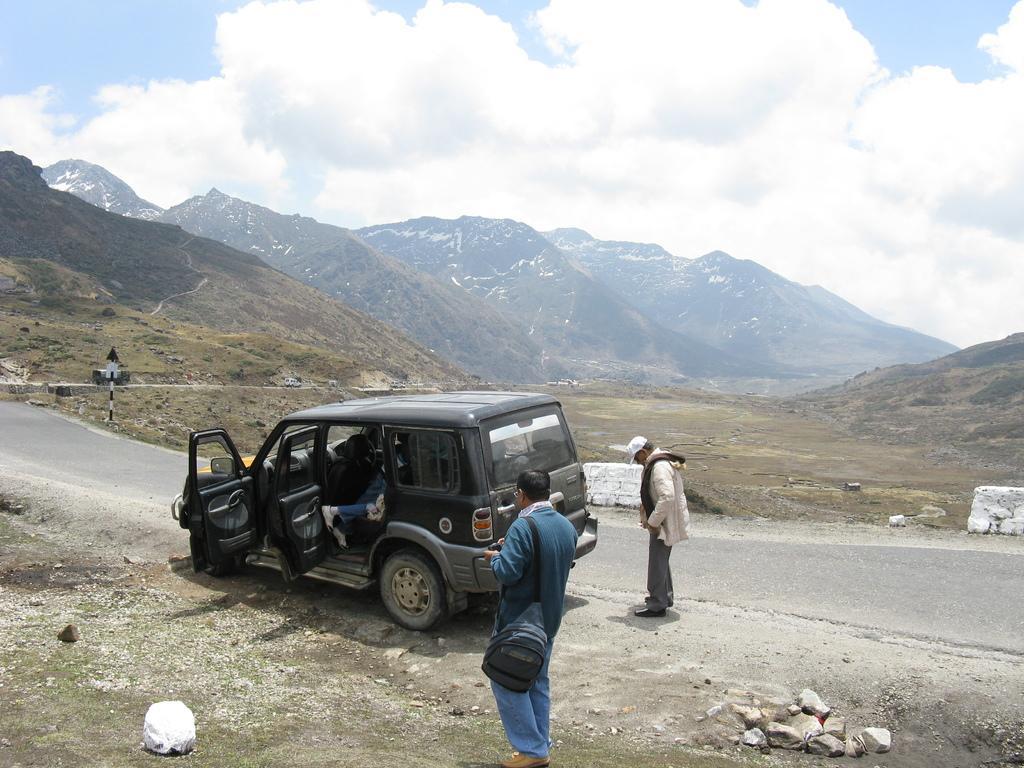In one or two sentences, can you explain what this image depicts? In this image, we can see persons standing and wearing clothes. There is a vehicle on the road. There are hills in the middle of the image. There is a sky at the top of the image. 